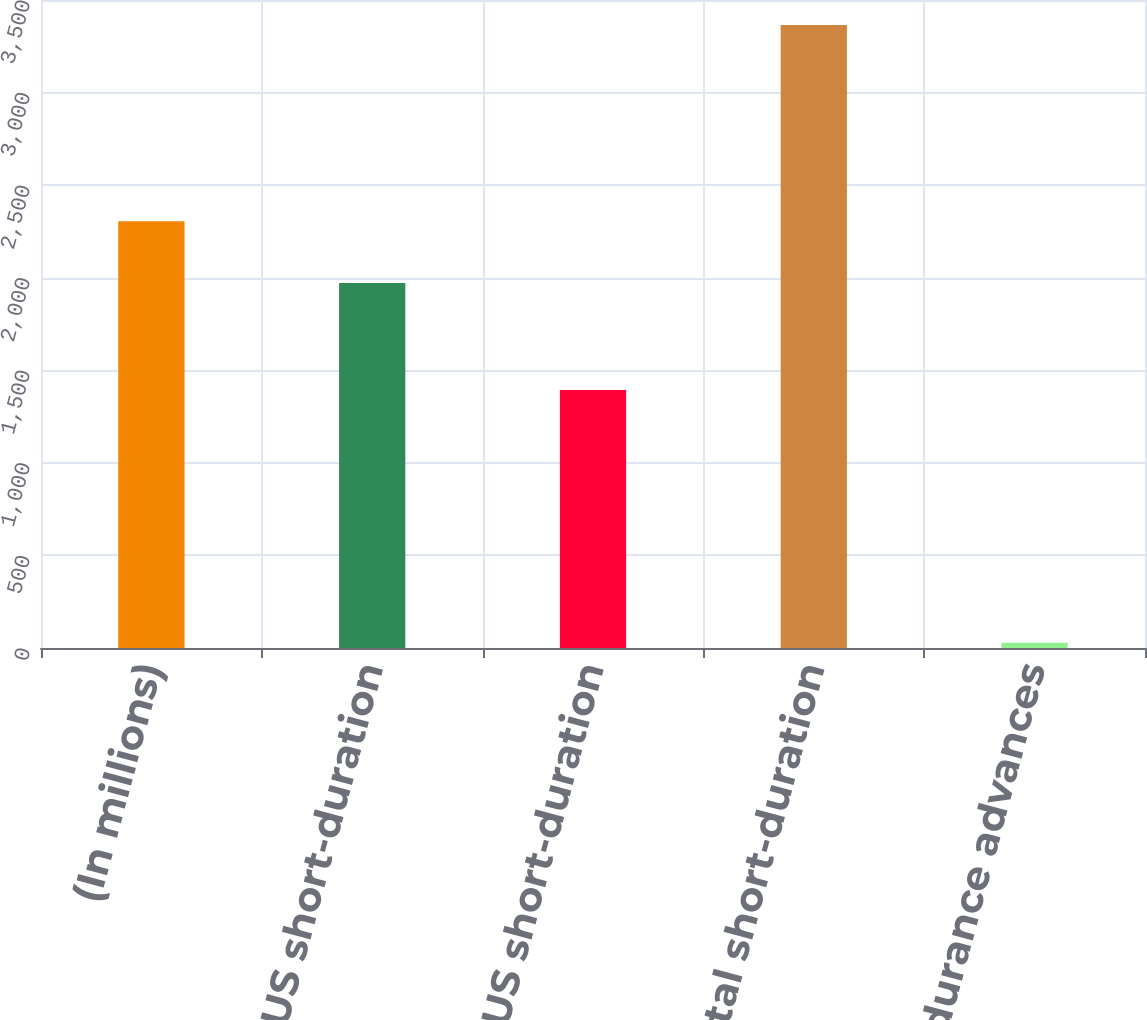Convert chart to OTSL. <chart><loc_0><loc_0><loc_500><loc_500><bar_chart><fcel>(In millions)<fcel>Average US short-duration<fcel>Average non-US short-duration<fcel>Average total short-duration<fcel>Average short-durance advances<nl><fcel>2305.6<fcel>1972<fcel>1393<fcel>3365<fcel>29<nl></chart> 